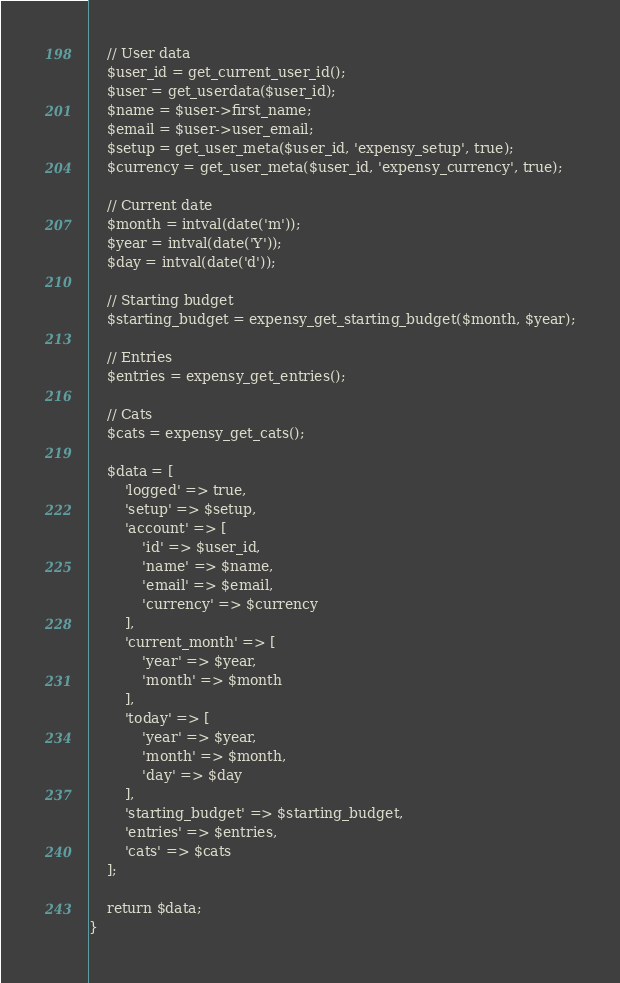<code> <loc_0><loc_0><loc_500><loc_500><_PHP_>
    // User data
    $user_id = get_current_user_id();
    $user = get_userdata($user_id);
    $name = $user->first_name;
    $email = $user->user_email;
    $setup = get_user_meta($user_id, 'expensy_setup', true);
    $currency = get_user_meta($user_id, 'expensy_currency', true);

    // Current date
    $month = intval(date('m'));
    $year = intval(date('Y'));
    $day = intval(date('d'));

    // Starting budget
    $starting_budget = expensy_get_starting_budget($month, $year);

    // Entries
    $entries = expensy_get_entries();

    // Cats
    $cats = expensy_get_cats();

    $data = [
        'logged' => true,
        'setup' => $setup,
        'account' => [
            'id' => $user_id,
            'name' => $name,
            'email' => $email,
            'currency' => $currency
        ],
        'current_month' => [
            'year' => $year,
            'month' => $month
        ],
        'today' => [
            'year' => $year,
            'month' => $month,
            'day' => $day
        ],
        'starting_budget' => $starting_budget,
        'entries' => $entries,
        'cats' => $cats
    ];

    return $data;
}
</code> 